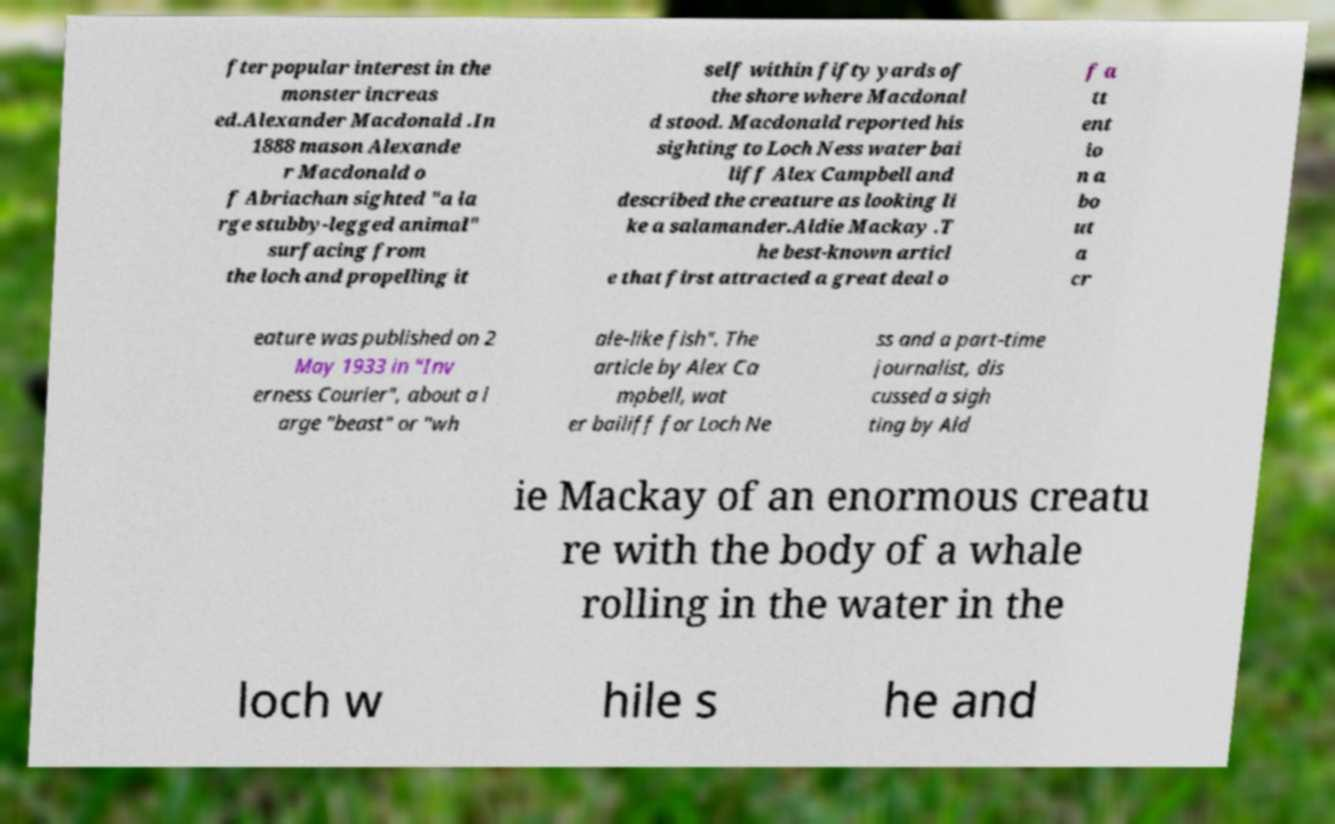Could you assist in decoding the text presented in this image and type it out clearly? fter popular interest in the monster increas ed.Alexander Macdonald .In 1888 mason Alexande r Macdonald o f Abriachan sighted "a la rge stubby-legged animal" surfacing from the loch and propelling it self within fifty yards of the shore where Macdonal d stood. Macdonald reported his sighting to Loch Ness water bai liff Alex Campbell and described the creature as looking li ke a salamander.Aldie Mackay .T he best-known articl e that first attracted a great deal o f a tt ent io n a bo ut a cr eature was published on 2 May 1933 in "Inv erness Courier", about a l arge "beast" or "wh ale-like fish". The article by Alex Ca mpbell, wat er bailiff for Loch Ne ss and a part-time journalist, dis cussed a sigh ting by Ald ie Mackay of an enormous creatu re with the body of a whale rolling in the water in the loch w hile s he and 